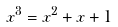<formula> <loc_0><loc_0><loc_500><loc_500>x ^ { 3 } = x ^ { 2 } + x + 1</formula> 